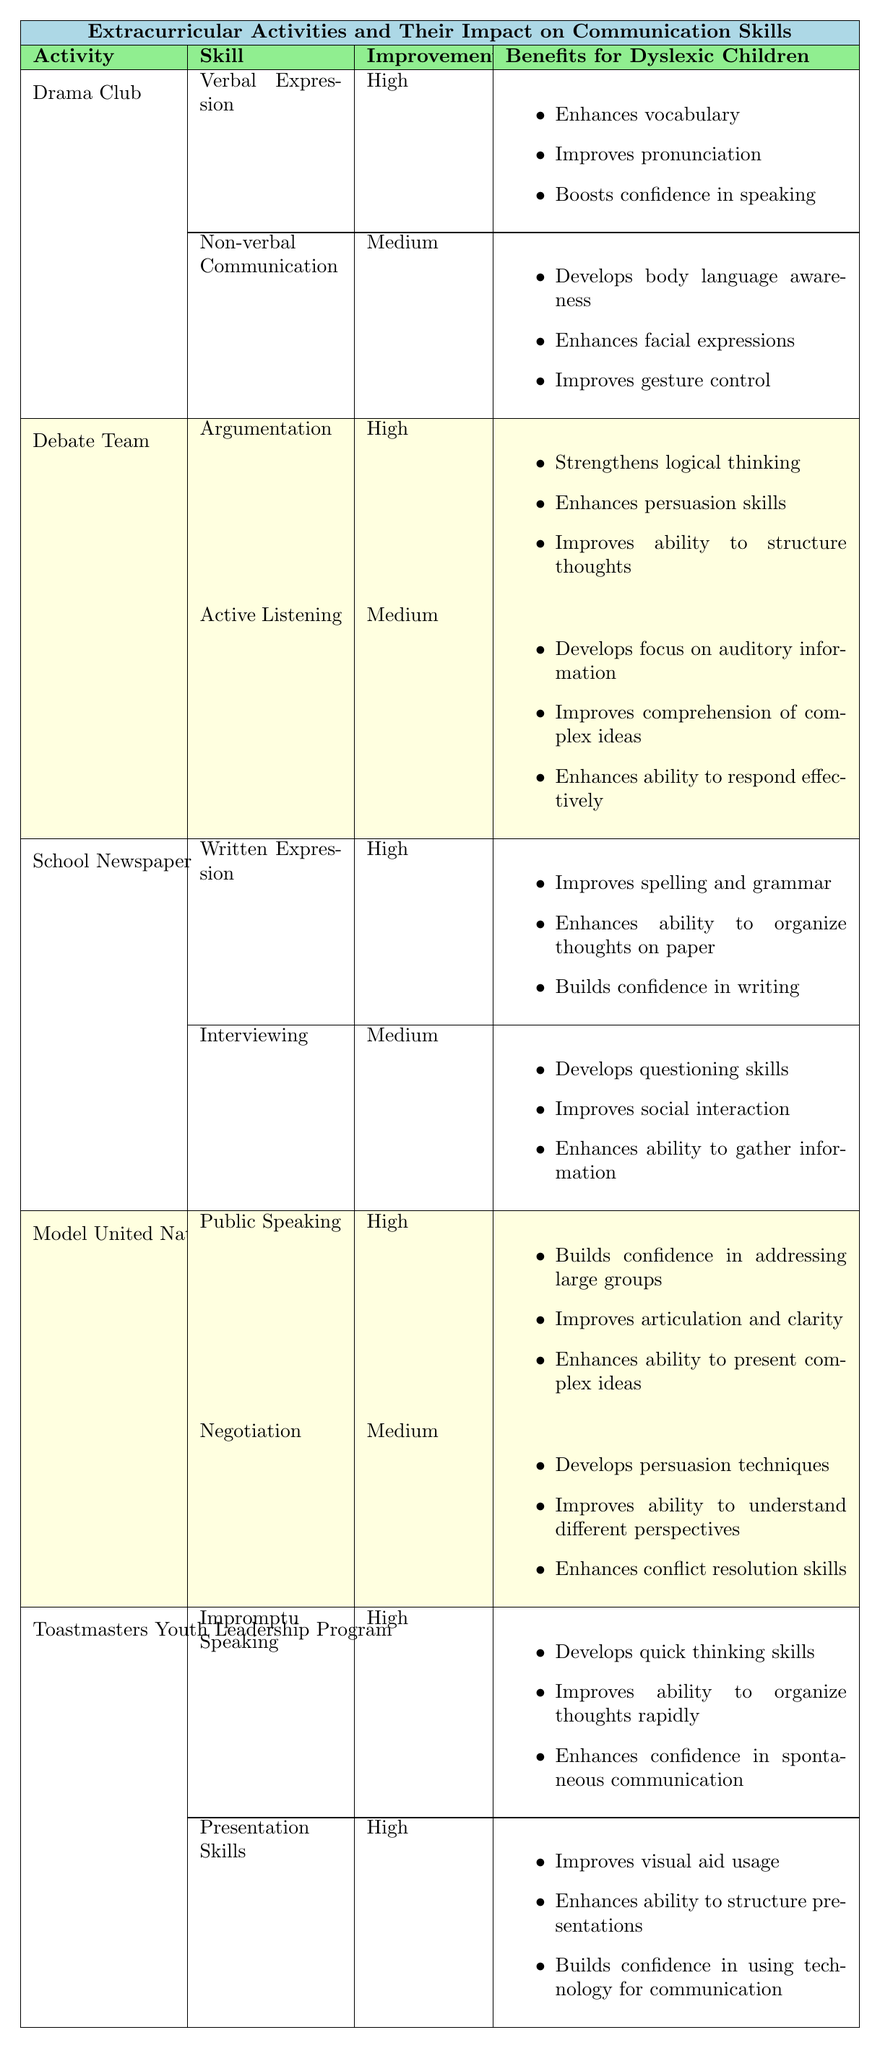What are the two impact skills learned in the Drama Club? The Drama Club has two communication skills listed: Verbal Expression and Non-verbal Communication.
Answer: Verbal Expression and Non-verbal Communication Which extracurricular activity focuses on improving Written Expression? The School Newspaper is the activity that focuses on improving Written Expression according to the table.
Answer: School Newspaper How many activities have a high improvement rating for skills? The table lists five activities, each with at least one skill rated high, totaling seven high improvement ratings.
Answer: Seven Is Active Listening considered a skill that improves communication skills? Yes, Active Listening is listed as a skill in the Debate Team section, and it is marked as having a medium improvement rating.
Answer: Yes Which extracurricular activities help develop confidence in communication? The Drama Club, Model United Nations, and Toastmasters Youth Leadership Program all have benefits that build confidence in communication.
Answer: Three activities What two skills learned in the Debate Team show high improvement? In the Debate Team section, the skill Argumentation shows high improvement. Only this skill meets the requirement, with Active Listening at medium improvement.
Answer: Argumentation Which activity helps improve communication by developing questioning skills? The School Newspaper focuses on developing questioning skills, specifically under the Interviewing skill.
Answer: School Newspaper How does Toastmasters Youth Leadership Program improve quick thinking? The program helps develop quick thinking skills through the Impromptu Speaking skill, rated high in improvement.
Answer: Impromptu Speaking Do all activities listed have at least one skill with high improvement? Yes, all activities include at least one skill that is rated as having high improvement.
Answer: Yes Which activity provides skills in Negotiation and what improvement rating is associated with it? The Model United Nations activity provides skills in Negotiation, which has a medium improvement rating.
Answer: Model United Nations; Medium 